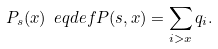Convert formula to latex. <formula><loc_0><loc_0><loc_500><loc_500>P _ { s } ( x ) \ e q d e f P ( s , x ) = \sum _ { i > x } q _ { i } .</formula> 